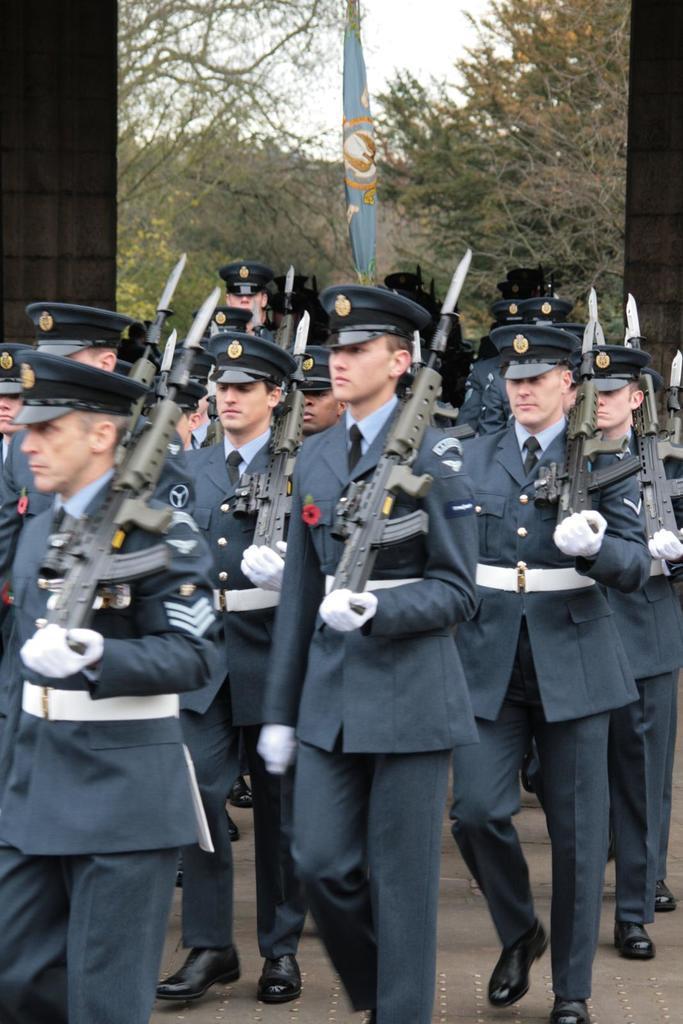Please provide a concise description of this image. There are people walking and holding guns and wire caps. In the background we can see flag, trees and sky. 